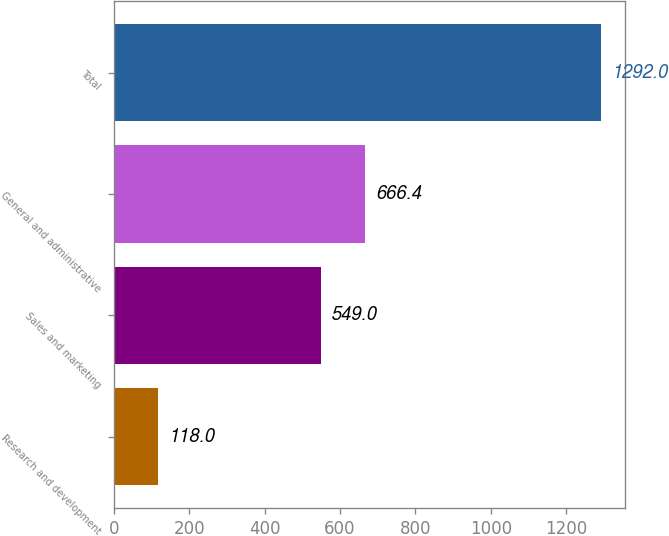<chart> <loc_0><loc_0><loc_500><loc_500><bar_chart><fcel>Research and development<fcel>Sales and marketing<fcel>General and administrative<fcel>Total<nl><fcel>118<fcel>549<fcel>666.4<fcel>1292<nl></chart> 